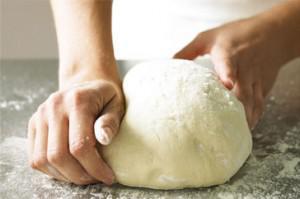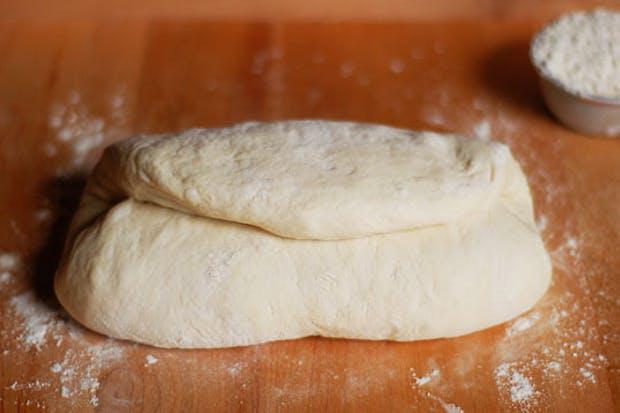The first image is the image on the left, the second image is the image on the right. Considering the images on both sides, is "IN at least one image there is kneaded bread next to a single bowl of flower." valid? Answer yes or no. Yes. 